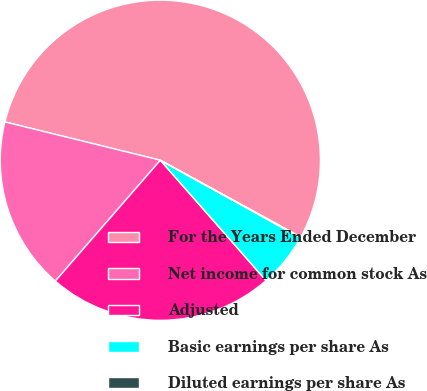Convert chart. <chart><loc_0><loc_0><loc_500><loc_500><pie_chart><fcel>For the Years Ended December<fcel>Net income for common stock As<fcel>Adjusted<fcel>Basic earnings per share As<fcel>Diluted earnings per share As<nl><fcel>54.11%<fcel>17.46%<fcel>22.86%<fcel>5.48%<fcel>0.08%<nl></chart> 